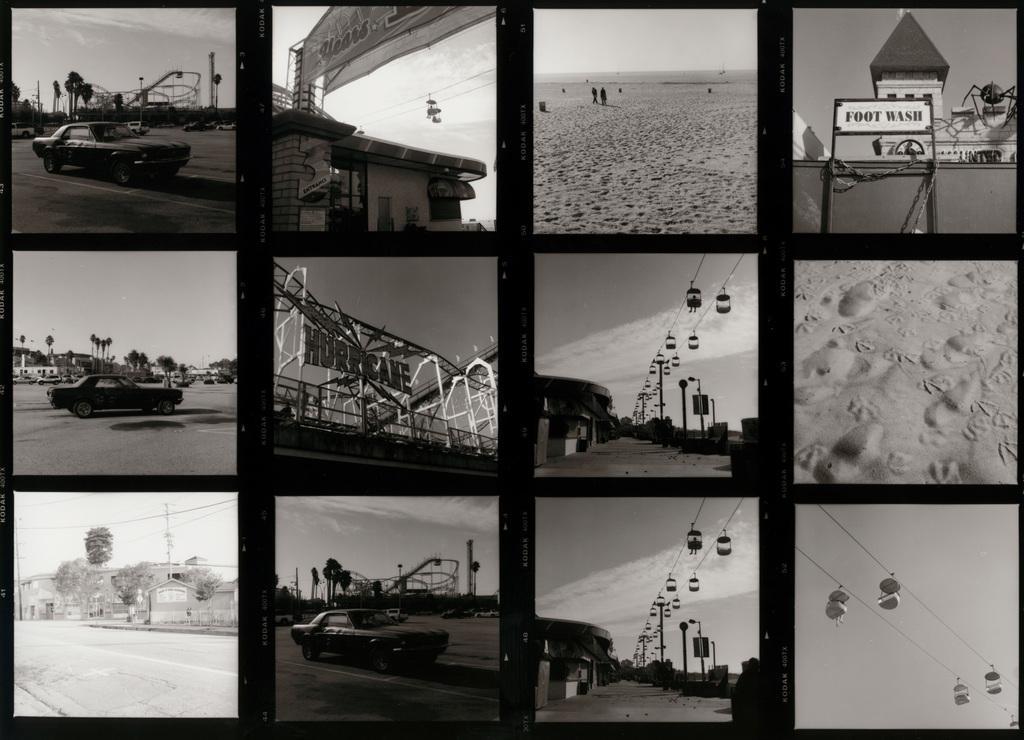In one or two sentences, can you explain what this image depicts? In this image I can see it is the photo collage and cars are moving on the road. On the right side there are skyways. 